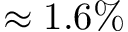<formula> <loc_0><loc_0><loc_500><loc_500>\approx 1 . 6 \%</formula> 